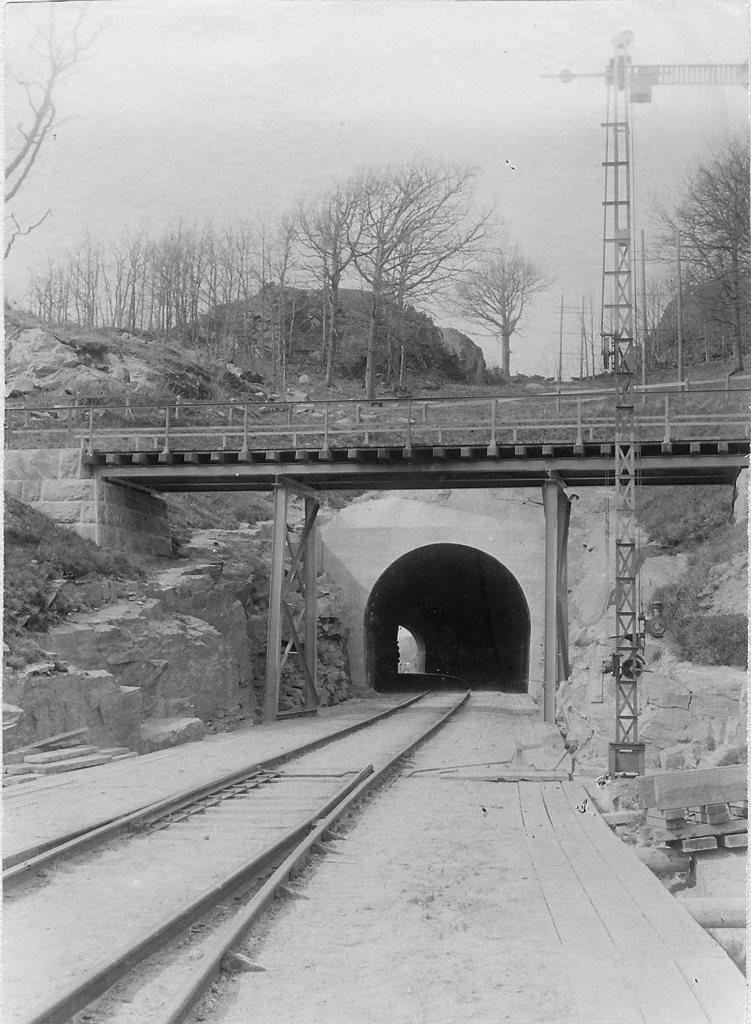What type of transportation infrastructure is present in the image? There is a railway track in the image. What structure can be seen at the top of the image? There is a bridge visible at the top of the image. What type of vegetation is present in the image? Trees are present in the image. What is visible in the background of the image? The sky is visible in the image. How many sisters are standing near the railway track in the image? There are no sisters present in the image. Can you see a giraffe grazing near the trees in the image? There is no giraffe present in the image; it is not a native animal to the environment depicted. 